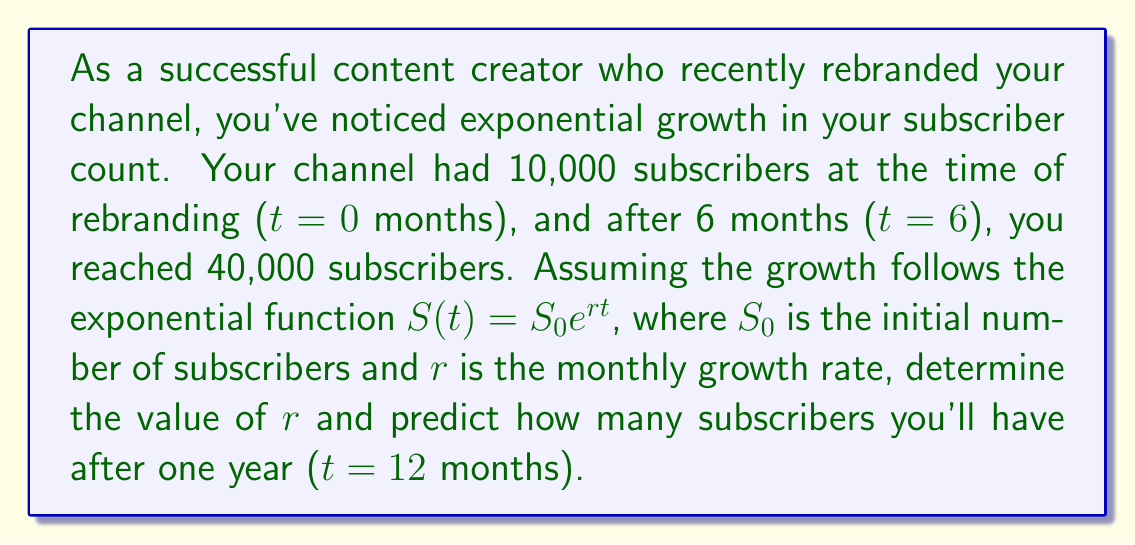Help me with this question. To solve this problem, we'll follow these steps:

1) We know the exponential function for subscriber growth is:
   $S(t) = S_0e^{rt}$

2) We have two data points:
   At t = 0: $S(0) = 10,000$
   At t = 6: $S(6) = 40,000$

3) Let's use the t = 0 data point to confirm $S_0$:
   $10,000 = S_0e^{r(0)}$
   $10,000 = S_0$

4) Now, let's use the t = 6 data point to find r:
   $40,000 = 10,000e^{r(6)}$

5) Divide both sides by 10,000:
   $4 = e^{6r}$

6) Take the natural log of both sides:
   $\ln(4) = 6r$

7) Solve for r:
   $r = \frac{\ln(4)}{6} \approx 0.2310$

8) Now that we have r, we can predict the number of subscribers at t = 12:
   $S(12) = 10,000e^{0.2310(12)}$
   $S(12) = 10,000e^{2.7720}$
   $S(12) = 10,000(16)$
   $S(12) = 160,000$
Answer: The monthly growth rate $r$ is approximately 0.2310 or 23.10% per month. After one year (t = 12 months), the predicted number of subscribers will be 160,000. 